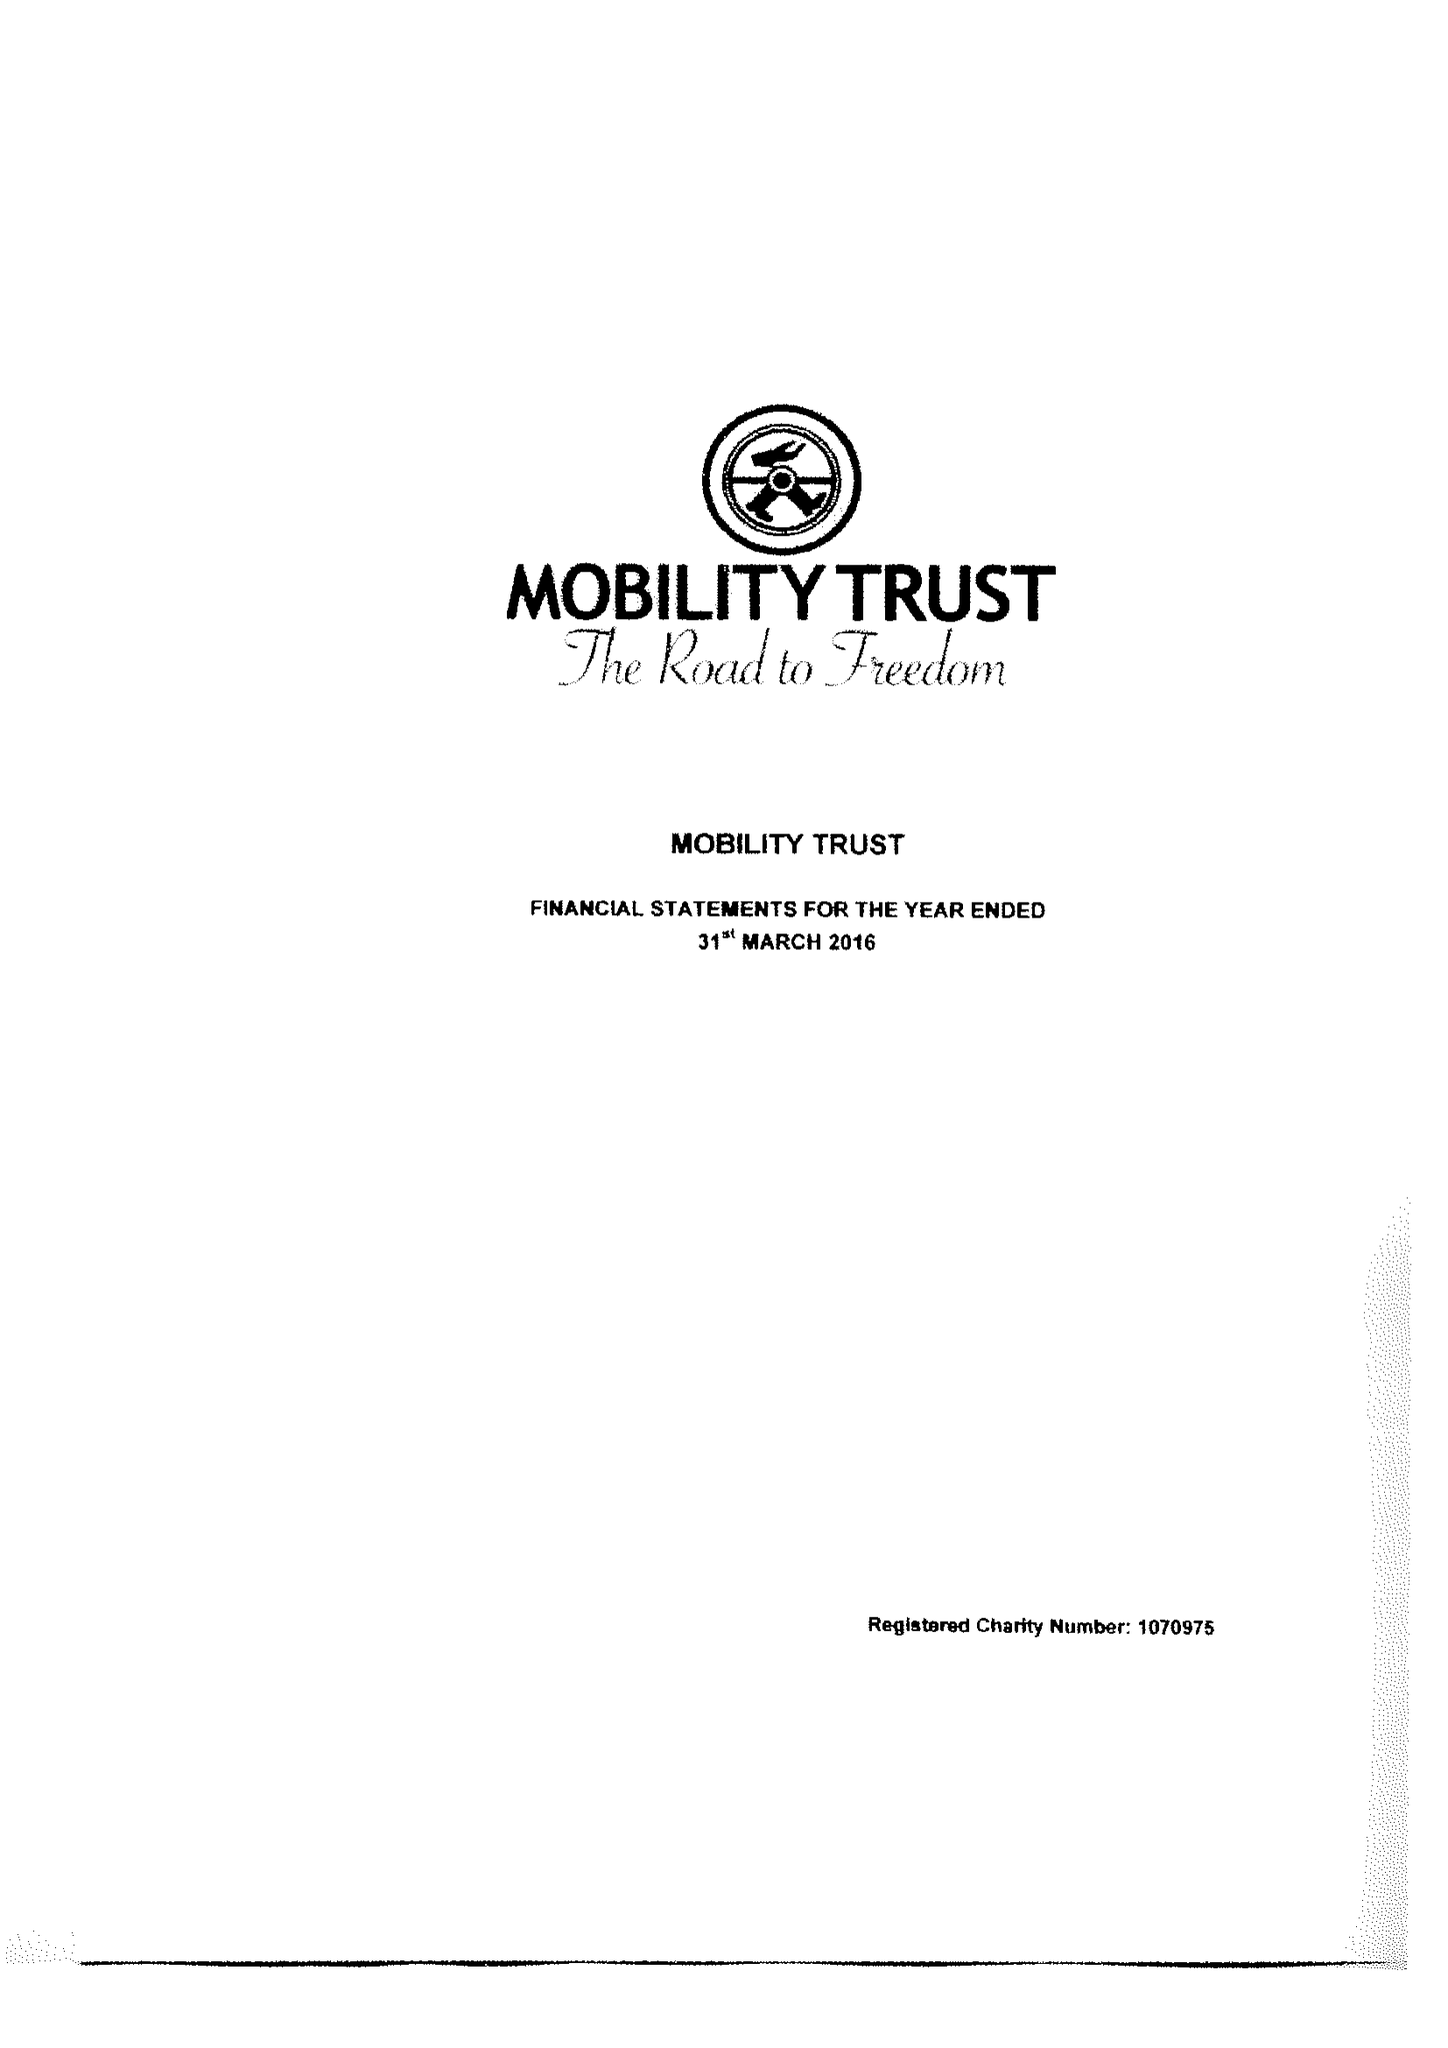What is the value for the address__postcode?
Answer the question using a single word or phrase. RG8 7LR 